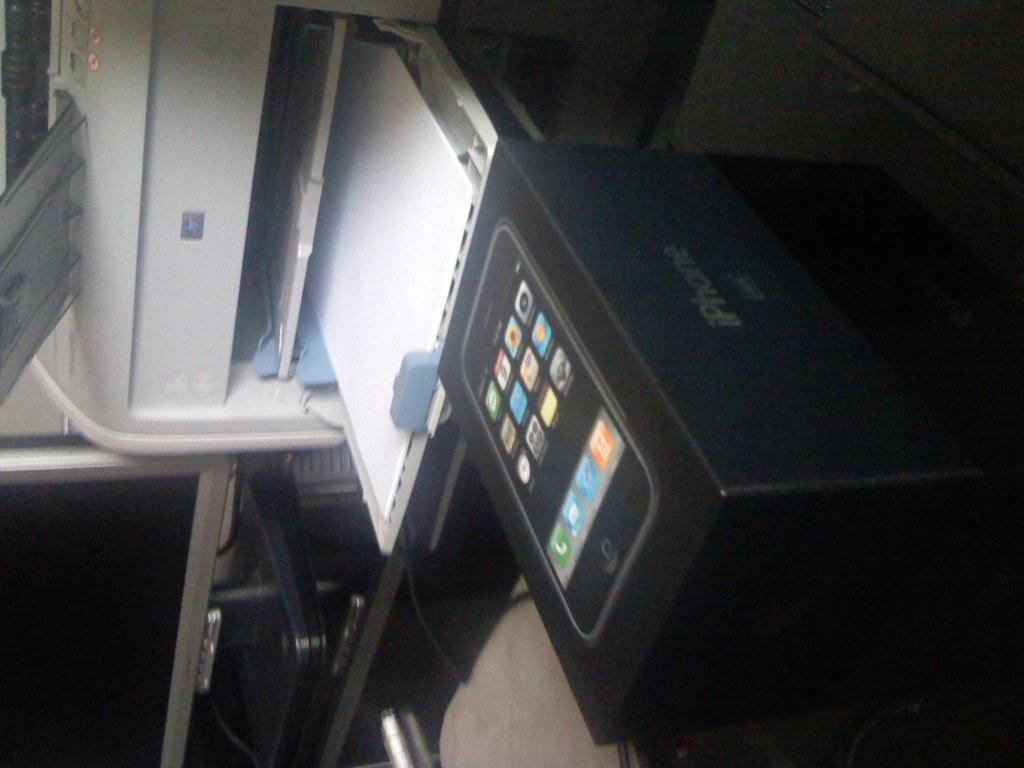<image>
Provide a brief description of the given image. An apple phone box sits on a table in front of a printer 